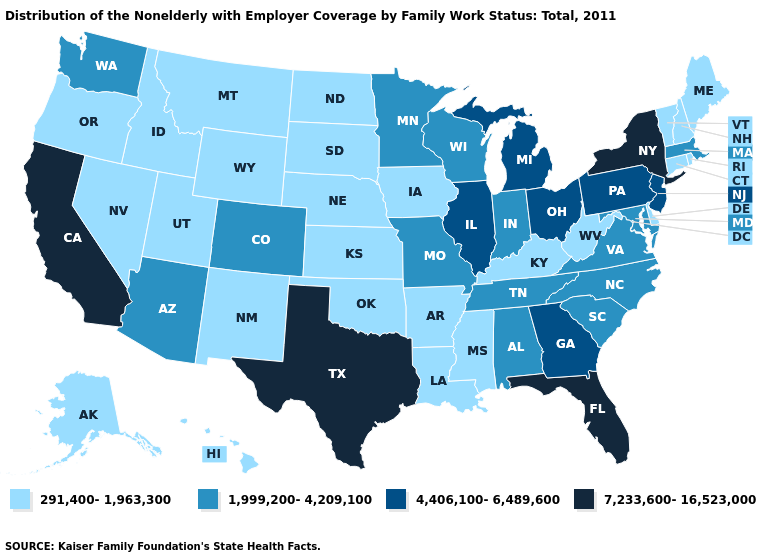Among the states that border Mississippi , does Arkansas have the lowest value?
Short answer required. Yes. Which states hav the highest value in the South?
Quick response, please. Florida, Texas. What is the value of Connecticut?
Short answer required. 291,400-1,963,300. Name the states that have a value in the range 291,400-1,963,300?
Be succinct. Alaska, Arkansas, Connecticut, Delaware, Hawaii, Idaho, Iowa, Kansas, Kentucky, Louisiana, Maine, Mississippi, Montana, Nebraska, Nevada, New Hampshire, New Mexico, North Dakota, Oklahoma, Oregon, Rhode Island, South Dakota, Utah, Vermont, West Virginia, Wyoming. Does the first symbol in the legend represent the smallest category?
Keep it brief. Yes. Name the states that have a value in the range 7,233,600-16,523,000?
Quick response, please. California, Florida, New York, Texas. Does Arizona have the highest value in the USA?
Give a very brief answer. No. What is the value of North Dakota?
Quick response, please. 291,400-1,963,300. Does Illinois have the highest value in the MidWest?
Quick response, please. Yes. Name the states that have a value in the range 1,999,200-4,209,100?
Short answer required. Alabama, Arizona, Colorado, Indiana, Maryland, Massachusetts, Minnesota, Missouri, North Carolina, South Carolina, Tennessee, Virginia, Washington, Wisconsin. What is the value of Washington?
Quick response, please. 1,999,200-4,209,100. Is the legend a continuous bar?
Write a very short answer. No. Does Illinois have the highest value in the MidWest?
Keep it brief. Yes. Does Kansas have the same value as New Jersey?
Quick response, please. No. What is the value of Georgia?
Keep it brief. 4,406,100-6,489,600. 